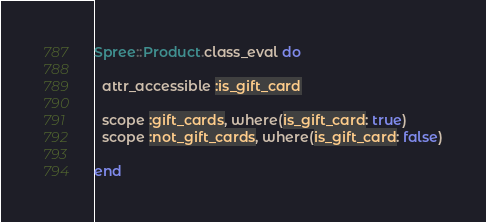<code> <loc_0><loc_0><loc_500><loc_500><_Ruby_>Spree::Product.class_eval do

  attr_accessible :is_gift_card

  scope :gift_cards, where(is_gift_card: true)
  scope :not_gift_cards, where(is_gift_card: false)

end
</code> 